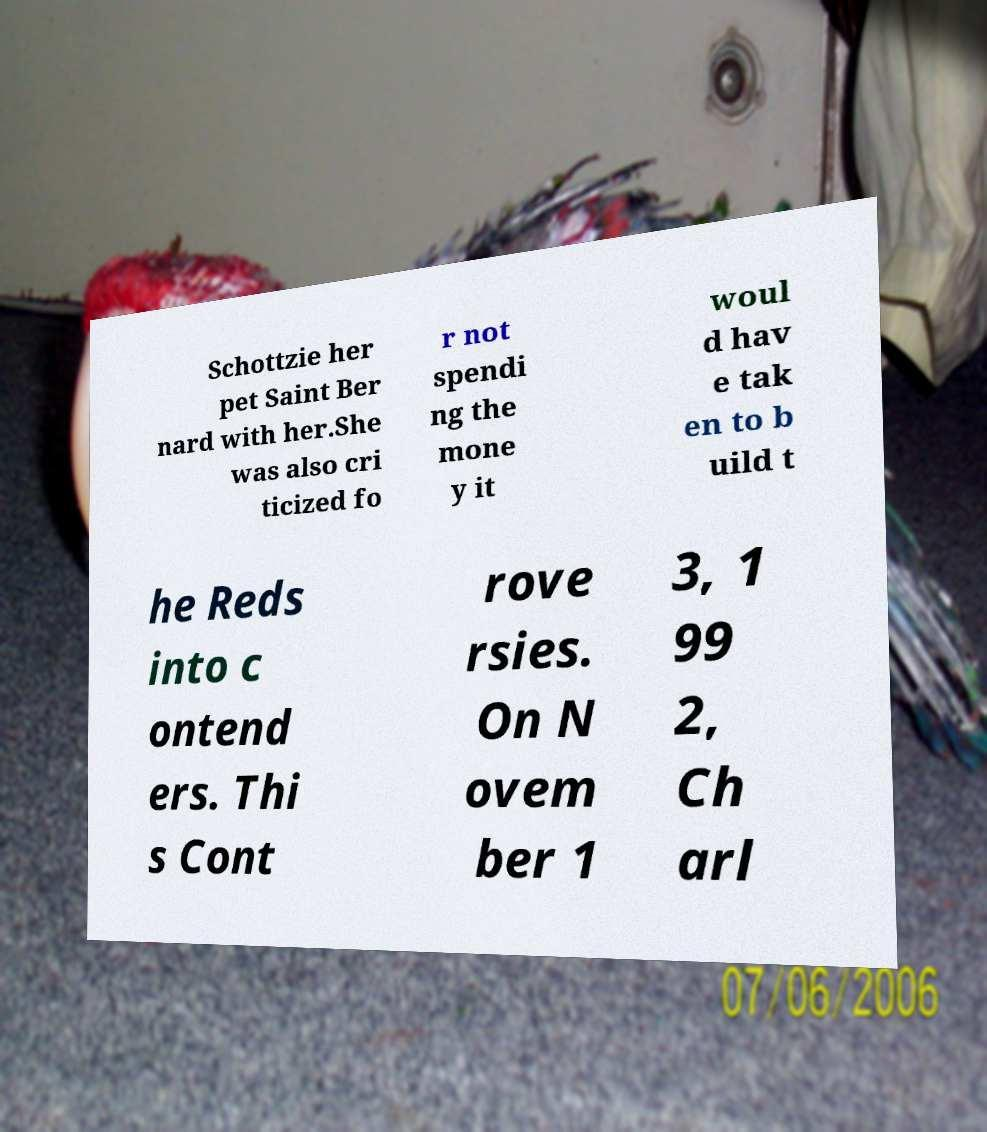Could you assist in decoding the text presented in this image and type it out clearly? Schottzie her pet Saint Ber nard with her.She was also cri ticized fo r not spendi ng the mone y it woul d hav e tak en to b uild t he Reds into c ontend ers. Thi s Cont rove rsies. On N ovem ber 1 3, 1 99 2, Ch arl 